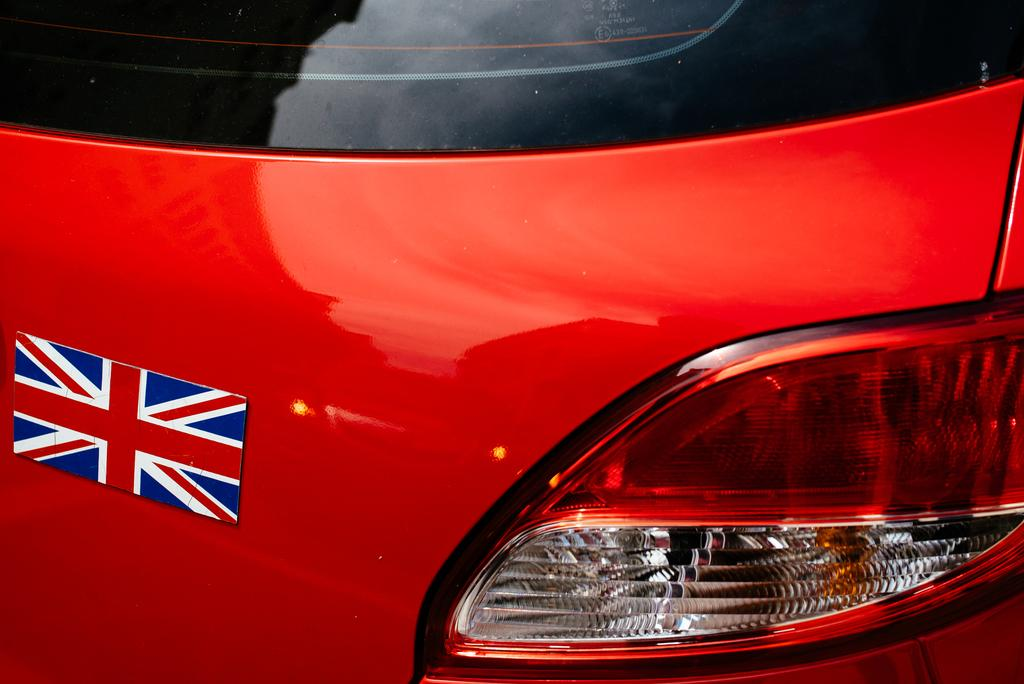What is attached to the car in the image? There is a flag on a car in the image. What safety feature is visible on the car? There is a brake light visible in the image. What allows passengers to see outside the car? There is a window on the car in the image. What type of hen can be seen participating in the hobbies of the car owner in the image? There is no hen or reference to hobbies present in the image; it features a flag on a car and a brake light. What is the bucket used for in the image? There is no bucket present in the image. 